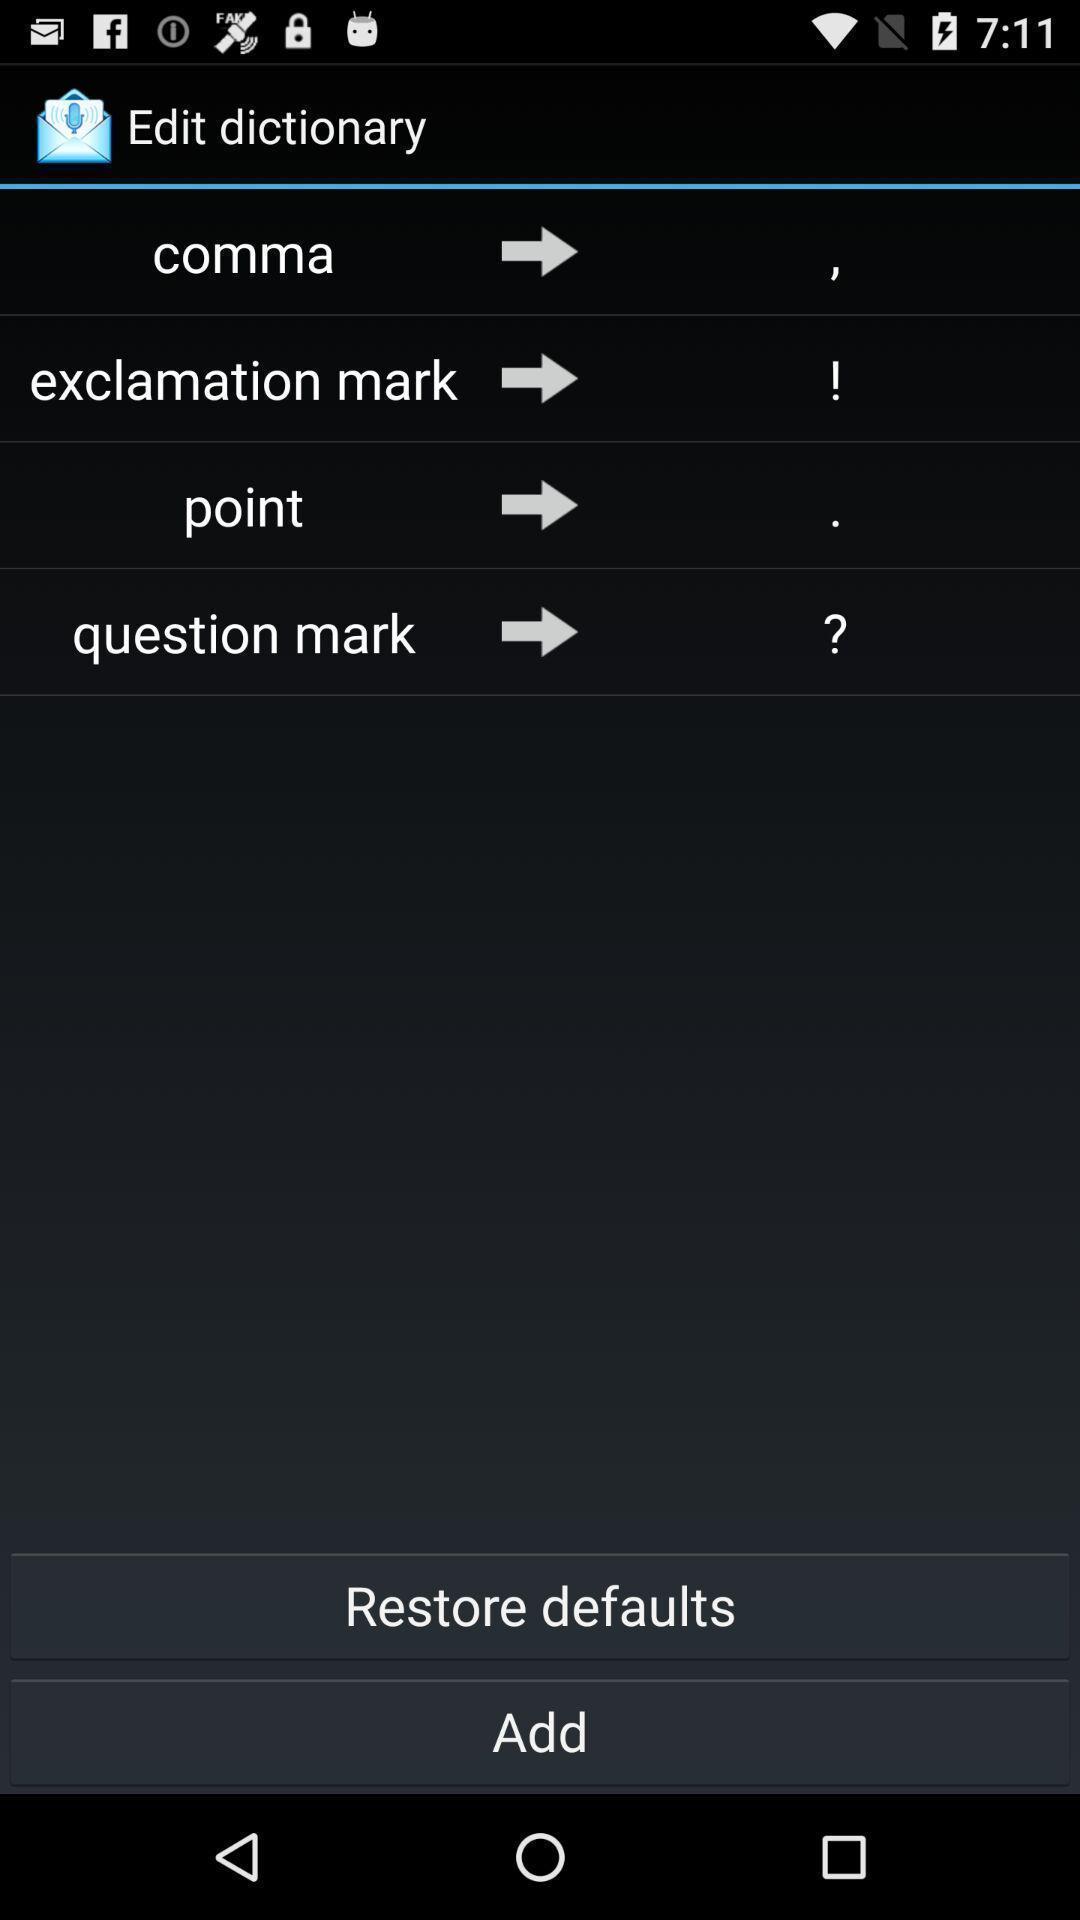Give me a summary of this screen capture. Window displaying a page for editing in dictionary. 